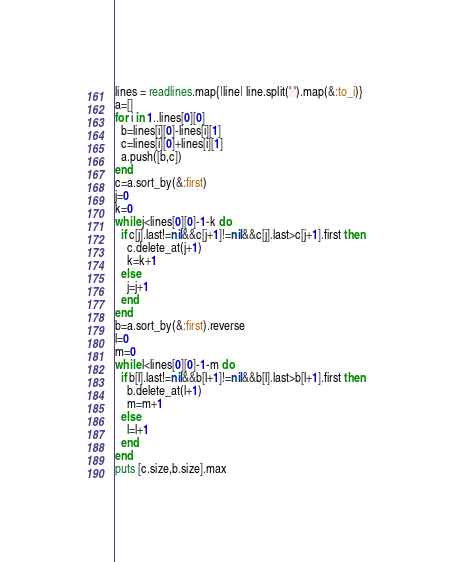Convert code to text. <code><loc_0><loc_0><loc_500><loc_500><_Ruby_>lines = readlines.map{|line| line.split(' ').map(&:to_i)}
a=[]
for i in 1..lines[0][0]
  b=lines[i][0]-lines[i][1]
  c=lines[i][0]+lines[i][1]
  a.push([b,c])
end
c=a.sort_by(&:first)
j=0
k=0
while j<lines[0][0]-1-k do
  if c[j].last!=nil&&c[j+1]!=nil&&c[j].last>c[j+1].first then
    c.delete_at(j+1)
    k=k+1
  else
    j=j+1
  end
end
b=a.sort_by(&:first).reverse
l=0
m=0
while l<lines[0][0]-1-m do
  if b[l].last!=nil&&b[l+1]!=nil&&b[l].last>b[l+1].first then
    b.delete_at(l+1)
    m=m+1
  else
    l=l+1
  end
end
puts [c.size,b.size].max</code> 